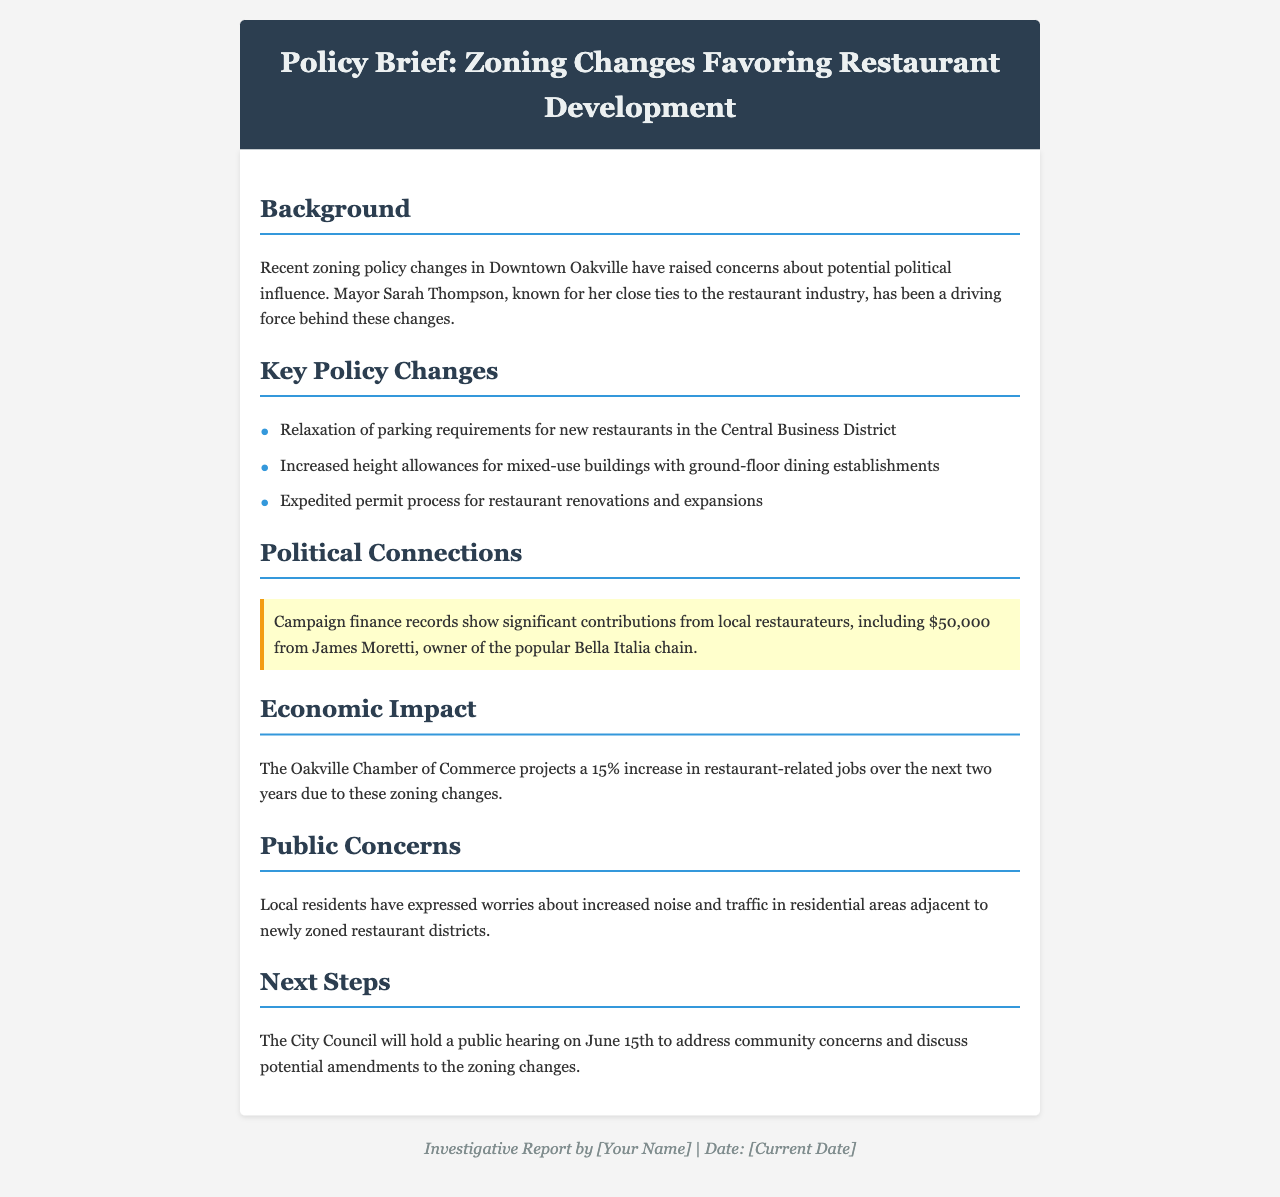What recent changes were made to zoning policy? The document states that there were recent zoning policy changes in Downtown Oakville.
Answer: Zoning policy changes in Downtown Oakville Who is the mayor associated with these changes? The document indicates that Mayor Sarah Thompson is known for her close ties to the restaurant industry and has been a driving force behind the changes.
Answer: Mayor Sarah Thompson How much did James Moretti contribute to the campaign? According to the campaign finance records mentioned, James Moretti contributed $50,000.
Answer: $50,000 What percentage increase in restaurant-related jobs is projected? The Oakville Chamber of Commerce projects a 15% increase in restaurant-related jobs due to these zoning changes.
Answer: 15% What is a concern mentioned by local residents? The document notes that local residents have expressed worries about increased noise and traffic.
Answer: Increased noise and traffic When will the City Council hold a public hearing? The document states that the City Council will hold a public hearing on June 15th.
Answer: June 15th What are the key changes to parking requirements? The key change mentioned is the relaxation of parking requirements for new restaurants in the Central Business District.
Answer: Relaxation of parking requirements What type of document is this titled as? The document is titled as a policy brief.
Answer: Policy brief 